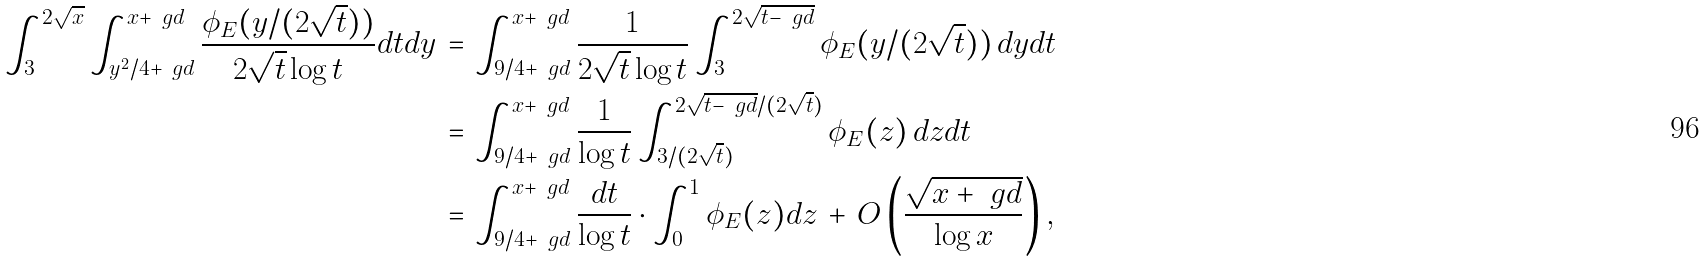Convert formula to latex. <formula><loc_0><loc_0><loc_500><loc_500>\int _ { 3 } ^ { 2 \sqrt { x } } \int _ { y ^ { 2 } / 4 + \ g d } ^ { x + \ g d } \frac { \phi _ { E } ( y / ( 2 \sqrt { t } ) ) } { 2 \sqrt { t } \log t } d t d y \, = & \, \int _ { 9 / 4 + \ g d } ^ { x + \ g d } \frac { 1 } { 2 \sqrt { t } \log t } \int _ { 3 } ^ { 2 \sqrt { t - \ g d } } \phi _ { E } ( y / ( 2 \sqrt { t } ) ) \, d y d t \\ = & \, \int _ { 9 / 4 + \ g d } ^ { x + \ g d } \frac { 1 } { \log t } \int _ { 3 / ( 2 \sqrt { t } ) } ^ { 2 \sqrt { t - \ g d } / ( 2 \sqrt { t } ) } \phi _ { E } ( z ) \, d z d t \\ = & \, \int _ { 9 / 4 + \ g d } ^ { x + \ g d } \frac { d t } { \log t } \cdot \int _ { 0 } ^ { 1 } \phi _ { E } ( z ) d z \, + \, O \left ( \frac { \sqrt { x + \ g d } } { \log x } \right ) ,</formula> 